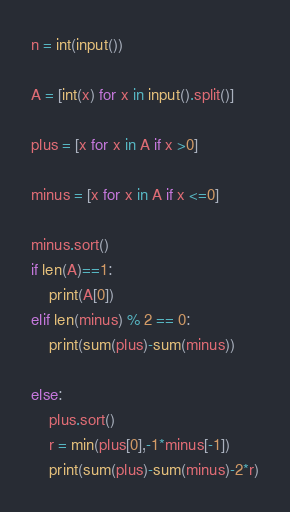<code> <loc_0><loc_0><loc_500><loc_500><_Python_>n = int(input())

A = [int(x) for x in input().split()]

plus = [x for x in A if x >0]

minus = [x for x in A if x <=0]

minus.sort()
if len(A)==1:
    print(A[0])
elif len(minus) % 2 == 0:
    print(sum(plus)-sum(minus))

else:
    plus.sort()
    r = min(plus[0],-1*minus[-1])
    print(sum(plus)-sum(minus)-2*r)
</code> 